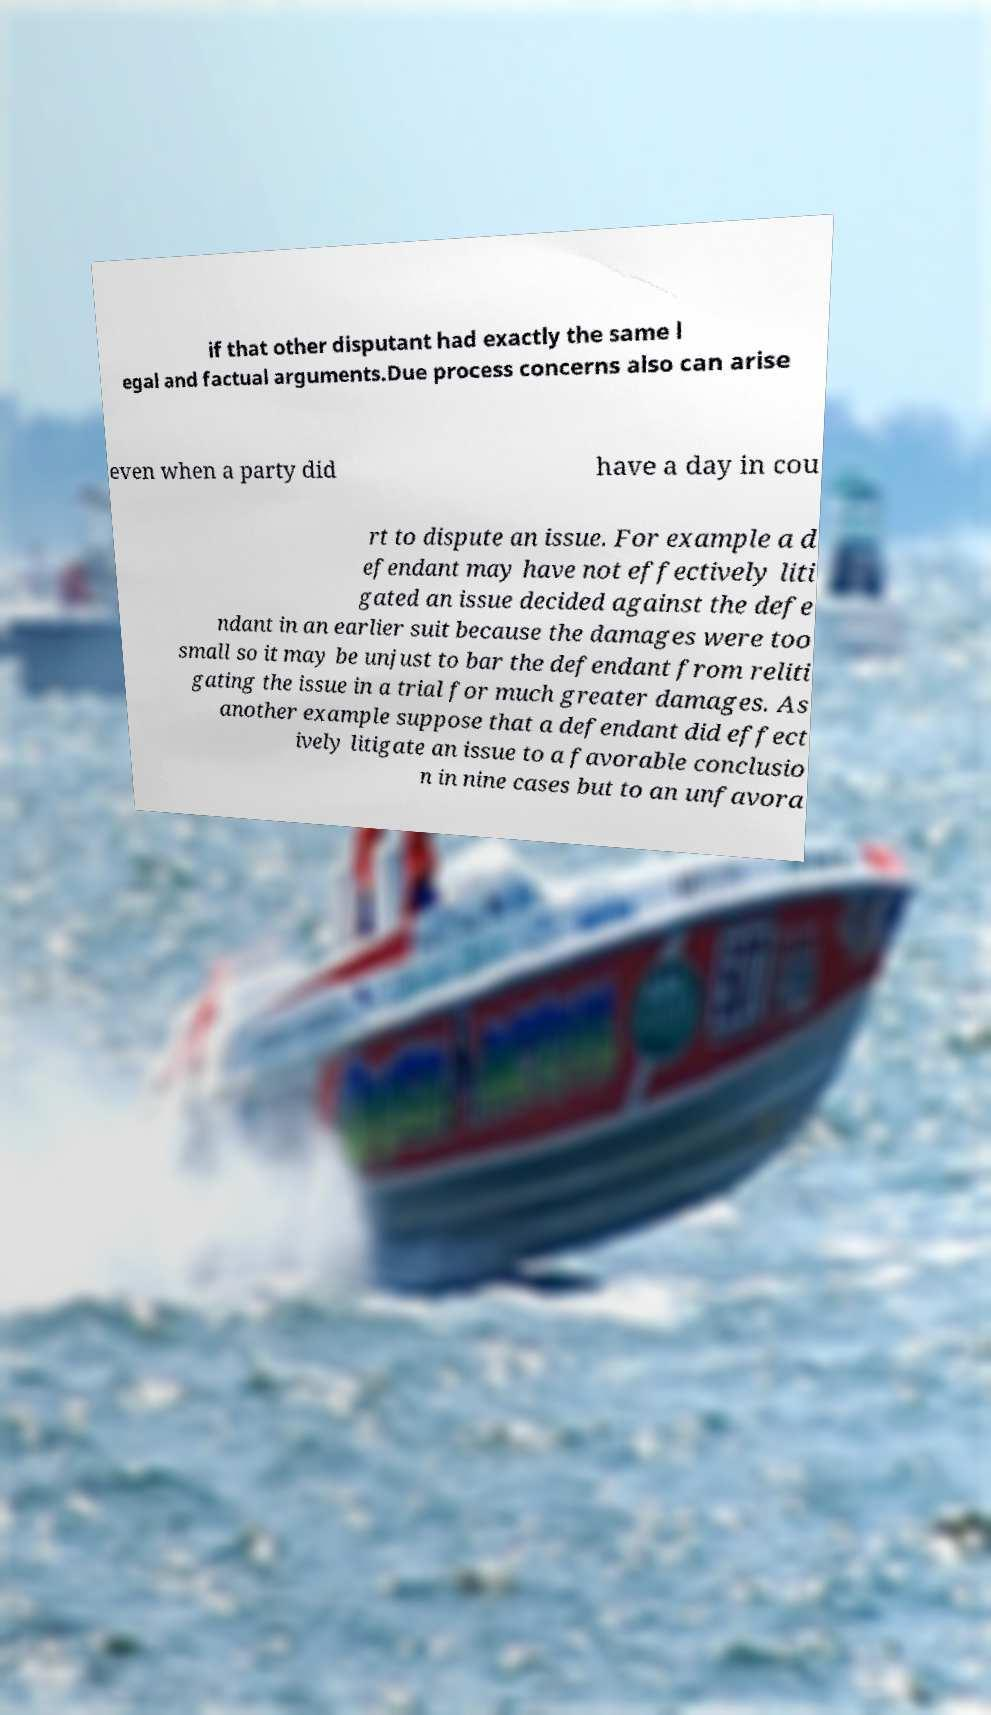I need the written content from this picture converted into text. Can you do that? if that other disputant had exactly the same l egal and factual arguments.Due process concerns also can arise even when a party did have a day in cou rt to dispute an issue. For example a d efendant may have not effectively liti gated an issue decided against the defe ndant in an earlier suit because the damages were too small so it may be unjust to bar the defendant from reliti gating the issue in a trial for much greater damages. As another example suppose that a defendant did effect ively litigate an issue to a favorable conclusio n in nine cases but to an unfavora 